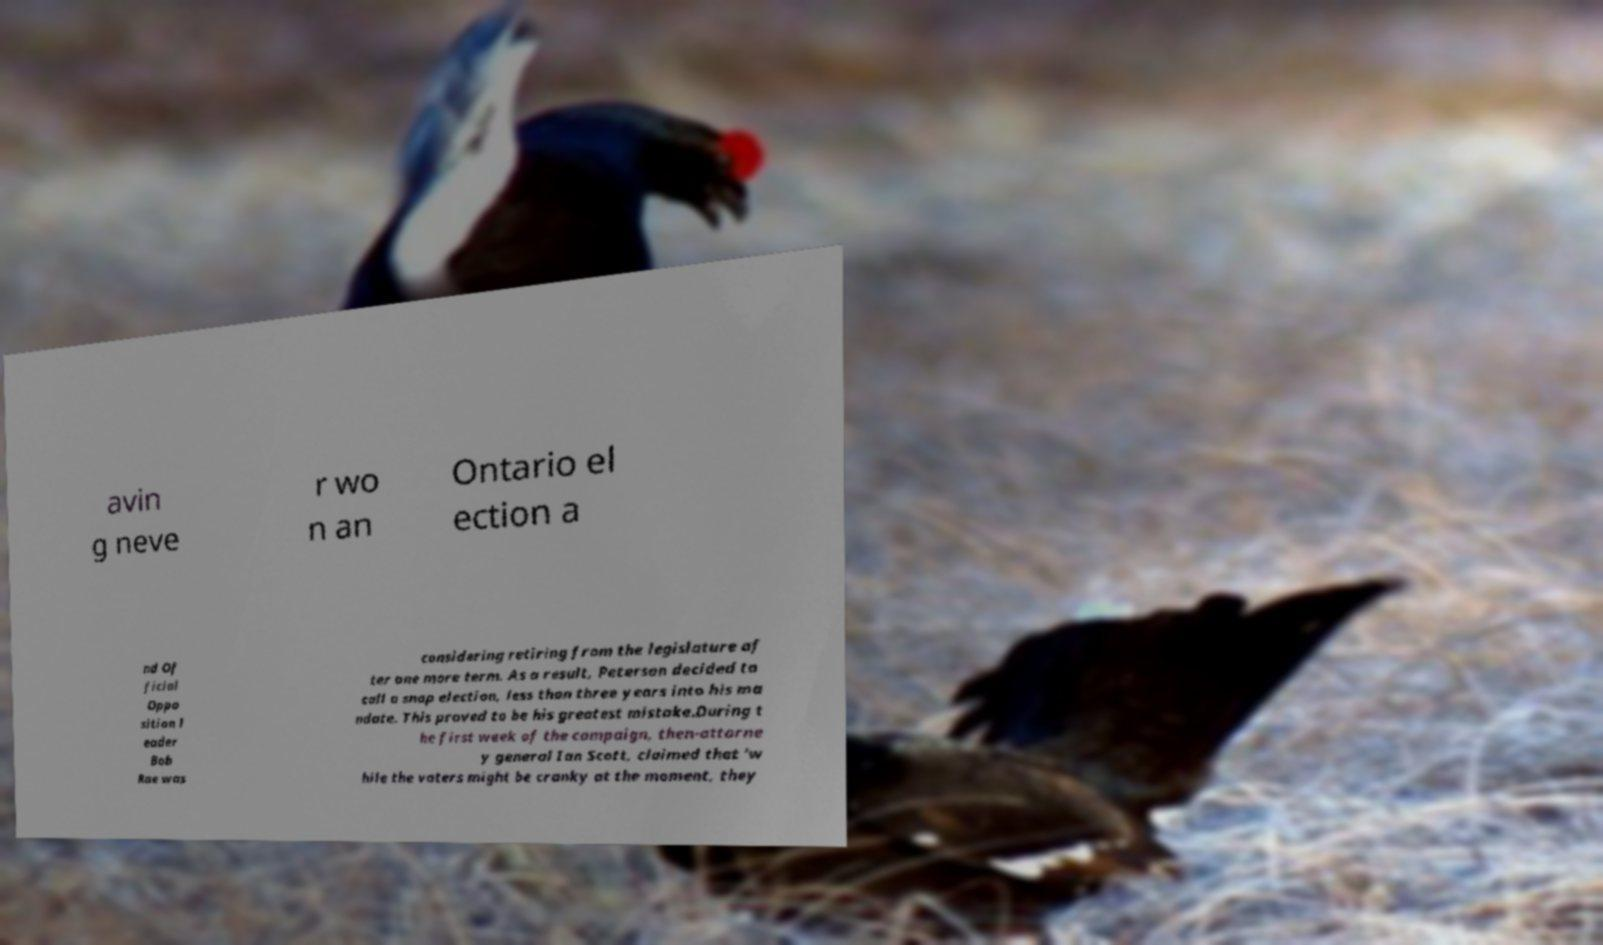Could you assist in decoding the text presented in this image and type it out clearly? avin g neve r wo n an Ontario el ection a nd Of ficial Oppo sition l eader Bob Rae was considering retiring from the legislature af ter one more term. As a result, Peterson decided to call a snap election, less than three years into his ma ndate. This proved to be his greatest mistake.During t he first week of the campaign, then-attorne y general Ian Scott, claimed that 'w hile the voters might be cranky at the moment, they 